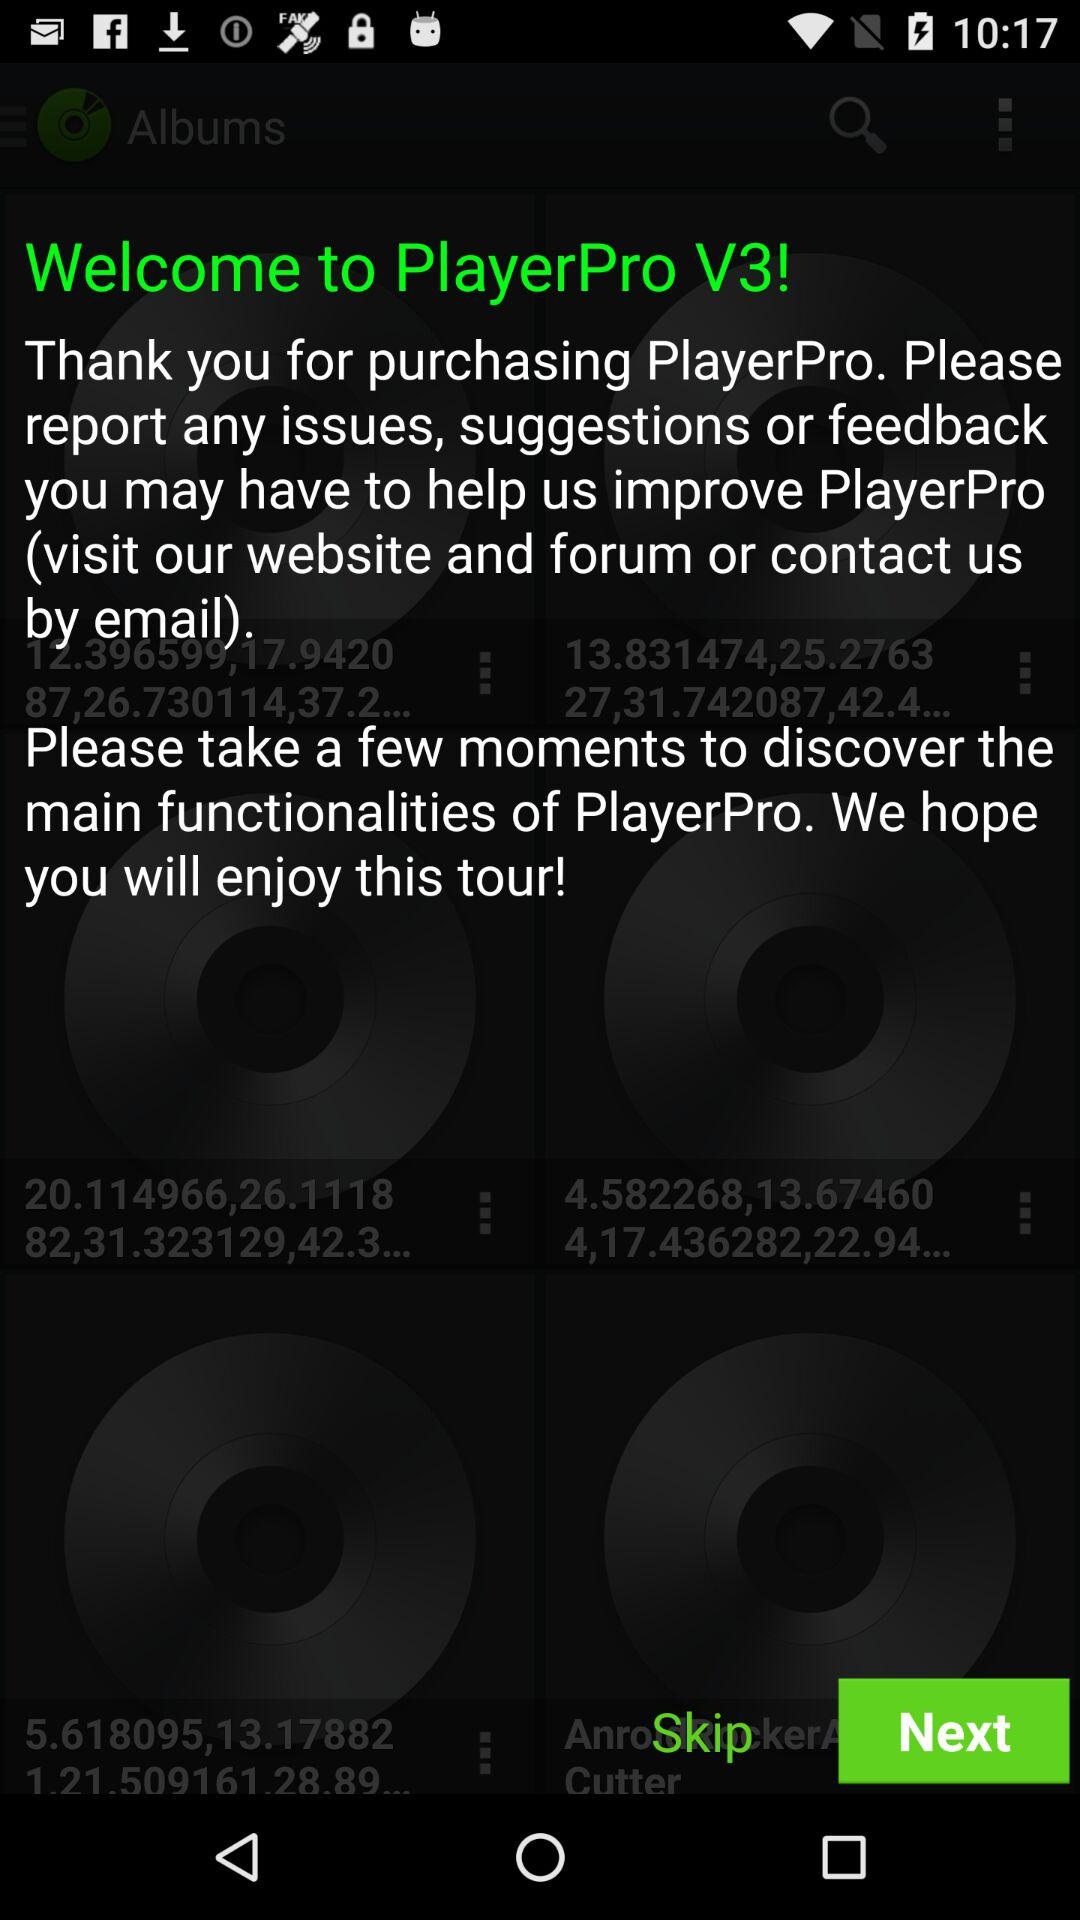What is the version of the application being used? The version is V3. 